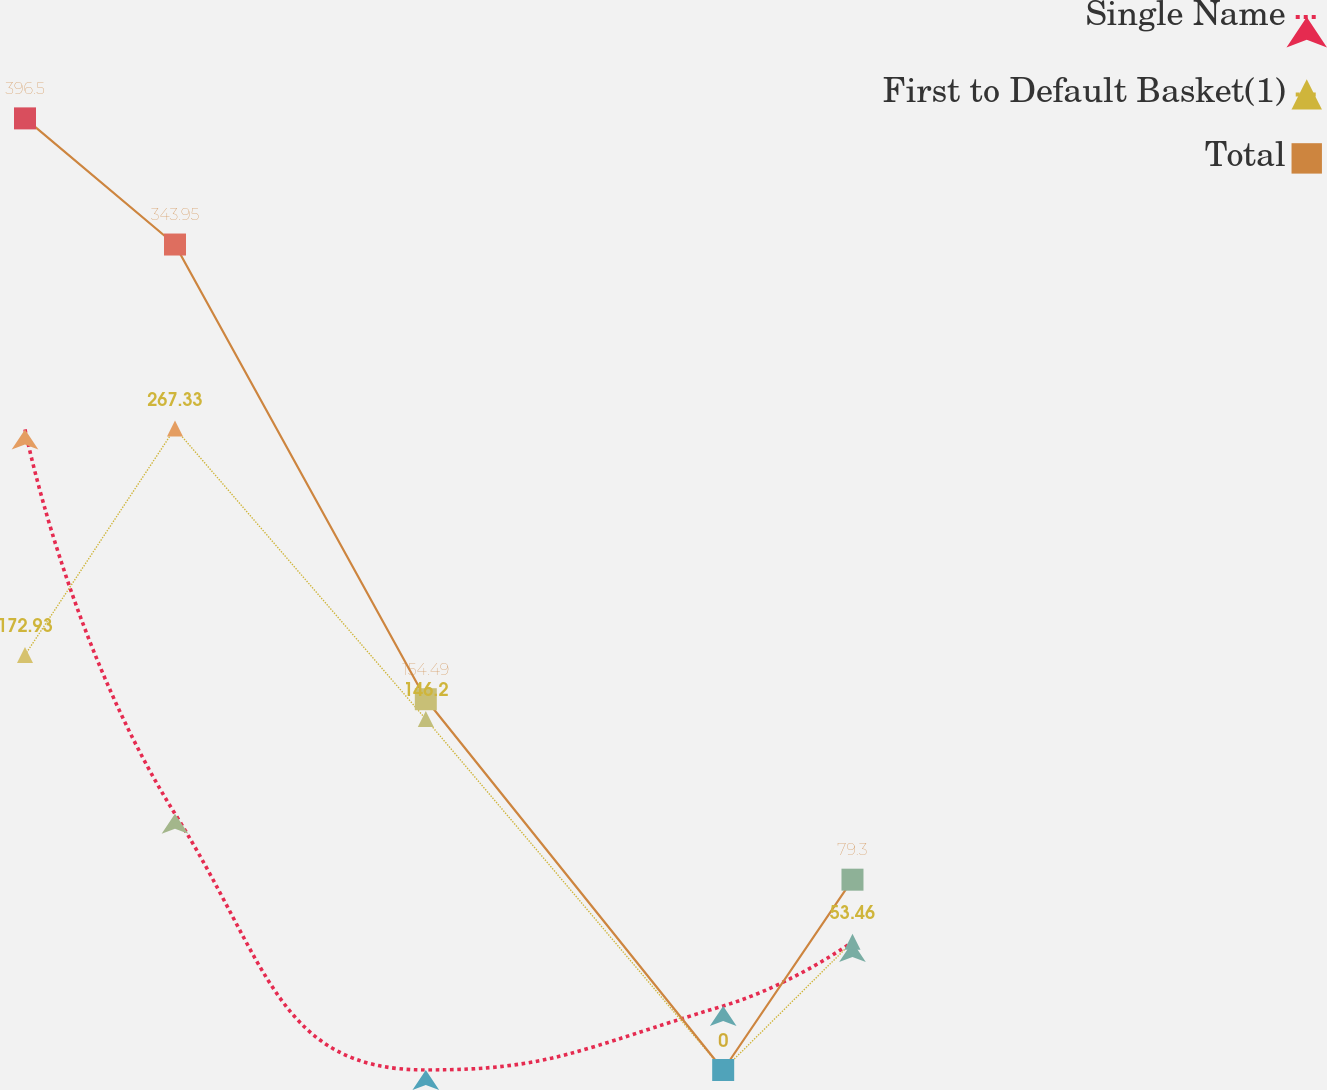Convert chart. <chart><loc_0><loc_0><loc_500><loc_500><line_chart><ecel><fcel>Single Name<fcel>First to Default Basket(1)<fcel>Total<nl><fcel>1.18<fcel>266.92<fcel>172.93<fcel>396.5<nl><fcel>1.76<fcel>106.76<fcel>267.33<fcel>343.95<nl><fcel>2.73<fcel>0<fcel>146.2<fcel>154.49<nl><fcel>3.88<fcel>26.69<fcel>0<fcel>0<nl><fcel>4.38<fcel>53.38<fcel>53.46<fcel>79.3<nl><fcel>6.13<fcel>80.07<fcel>26.73<fcel>39.65<nl></chart> 